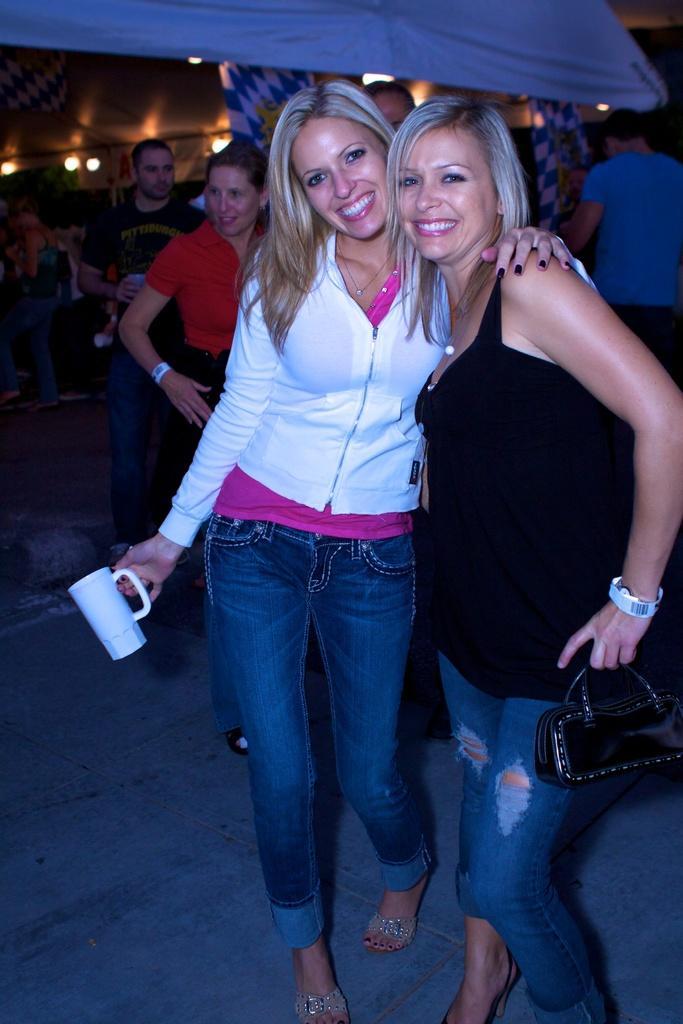Can you describe this image briefly? In this image we can see many people. One lady is holding a purse. Another lady is holding a glass. In the back we can see lights. 